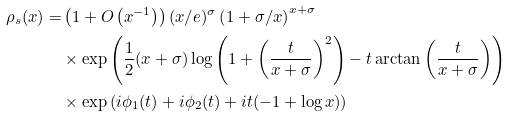<formula> <loc_0><loc_0><loc_500><loc_500>\rho _ { s } ( x ) = & \left ( 1 + O \left ( x ^ { - 1 } \right ) \right ) ( x / e ) ^ { \sigma } \left ( 1 + \sigma / x \right ) ^ { x + \sigma } \\ & \times \exp \left ( \frac { 1 } { 2 } ( x + \sigma ) \log \left ( 1 + \left ( \frac { t } { x + \sigma } \right ) ^ { 2 } \right ) - t \arctan \left ( \frac { t } { x + \sigma } \right ) \right ) \\ & \times \exp \left ( i \phi _ { 1 } ( t ) + i \phi _ { 2 } ( t ) + i t ( - 1 + \log x ) \right )</formula> 